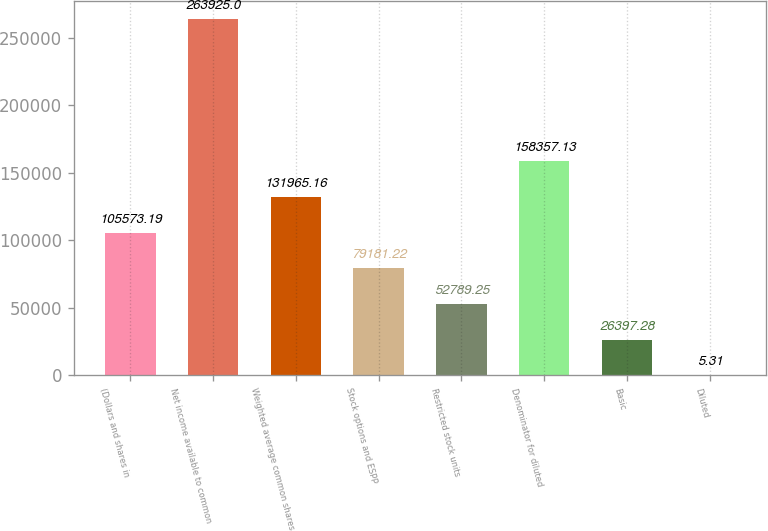Convert chart. <chart><loc_0><loc_0><loc_500><loc_500><bar_chart><fcel>(Dollars and shares in<fcel>Net income available to common<fcel>Weighted average common shares<fcel>Stock options and ESPP<fcel>Restricted stock units<fcel>Denominator for diluted<fcel>Basic<fcel>Diluted<nl><fcel>105573<fcel>263925<fcel>131965<fcel>79181.2<fcel>52789.2<fcel>158357<fcel>26397.3<fcel>5.31<nl></chart> 